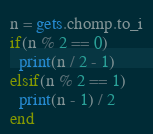<code> <loc_0><loc_0><loc_500><loc_500><_Ruby_>n = gets.chomp.to_i
if(n % 2 == 0)
  print(n / 2 - 1)
elsif(n % 2 == 1)
  print(n - 1) / 2
end</code> 